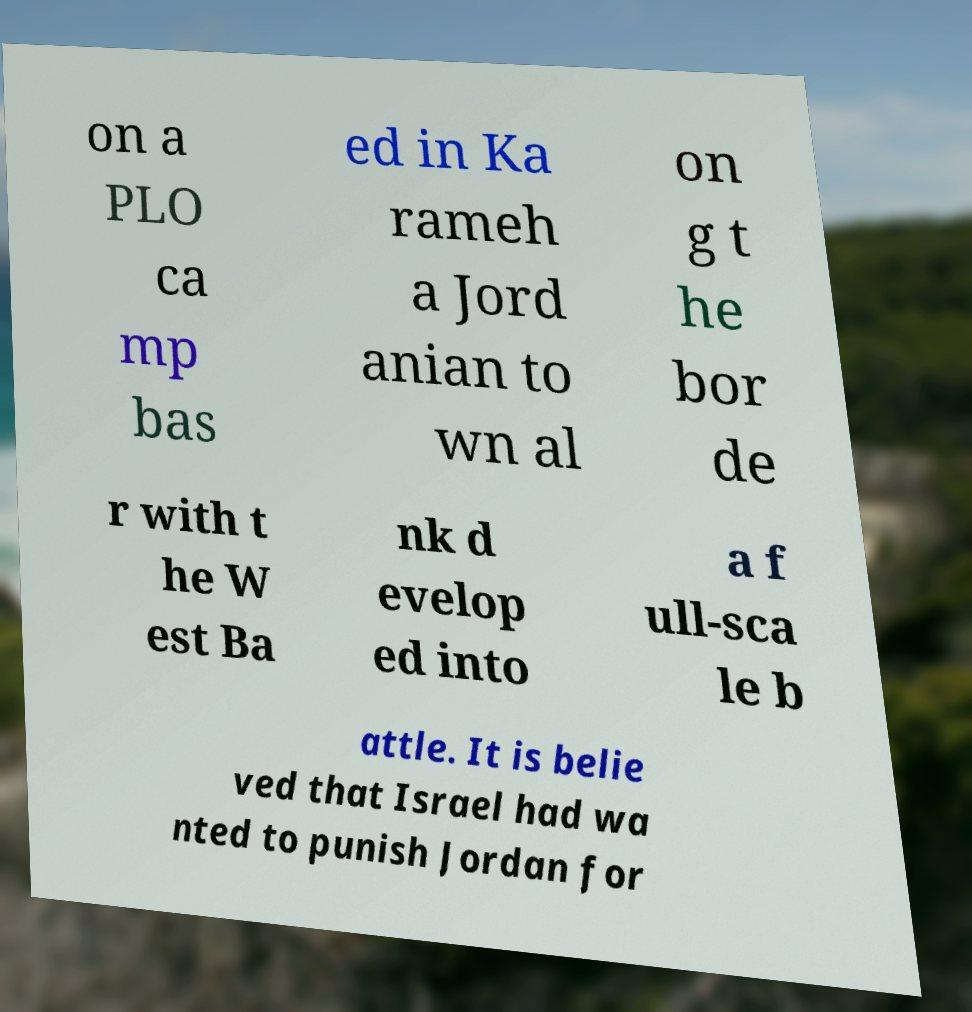Can you accurately transcribe the text from the provided image for me? on a PLO ca mp bas ed in Ka rameh a Jord anian to wn al on g t he bor de r with t he W est Ba nk d evelop ed into a f ull-sca le b attle. It is belie ved that Israel had wa nted to punish Jordan for 